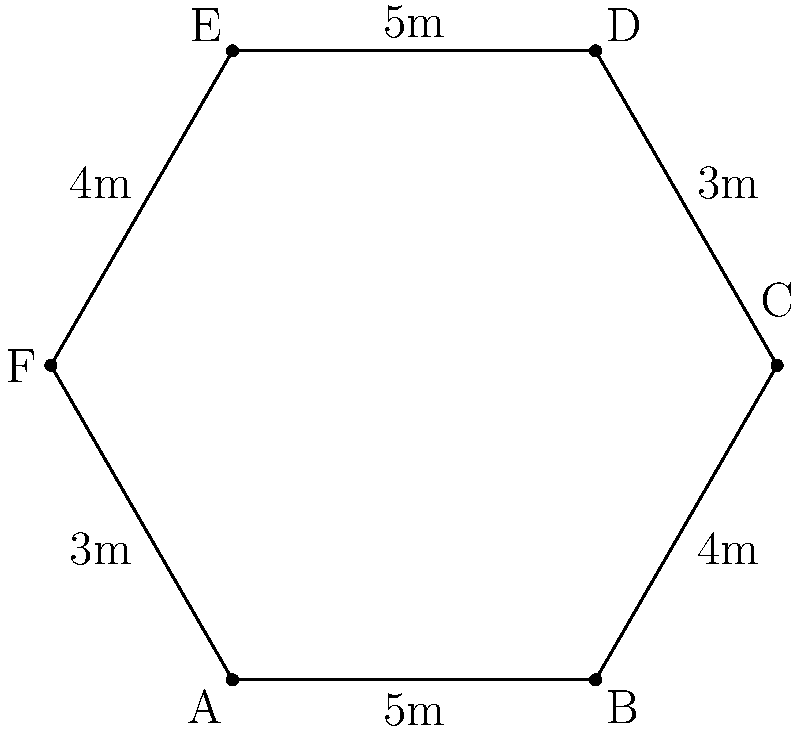As a cat shelter volunteer, you're designing a new hexagonal outdoor enclosure for the cats. The lengths of the sides are as shown in the diagram. What is the perimeter of this hexagonal cat enclosure? To find the perimeter of the hexagonal cat enclosure, we need to add up the lengths of all six sides. Let's go through this step-by-step:

1. Identify the lengths of each side:
   - Side AB = 5m
   - Side BC = 4m
   - Side CD = 3m
   - Side DE = 5m
   - Side EF = 4m
   - Side FA = 3m

2. Add up all the side lengths:
   $$\text{Perimeter} = 5m + 4m + 3m + 5m + 4m + 3m$$

3. Simplify the addition:
   $$\text{Perimeter} = 24m$$

Therefore, the perimeter of the hexagonal cat enclosure is 24 meters.
Answer: 24m 